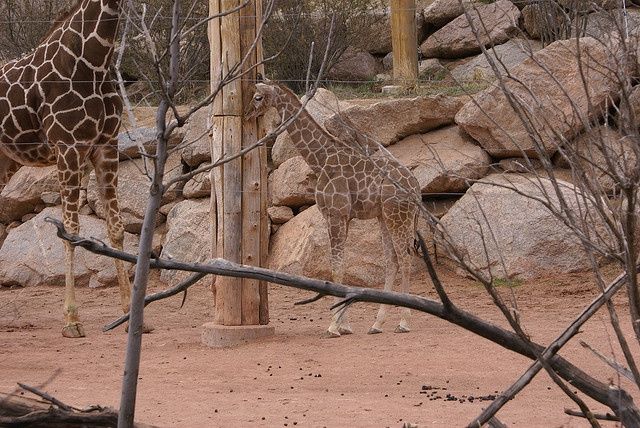Describe the objects in this image and their specific colors. I can see giraffe in gray, black, and maroon tones and giraffe in gray, brown, and maroon tones in this image. 